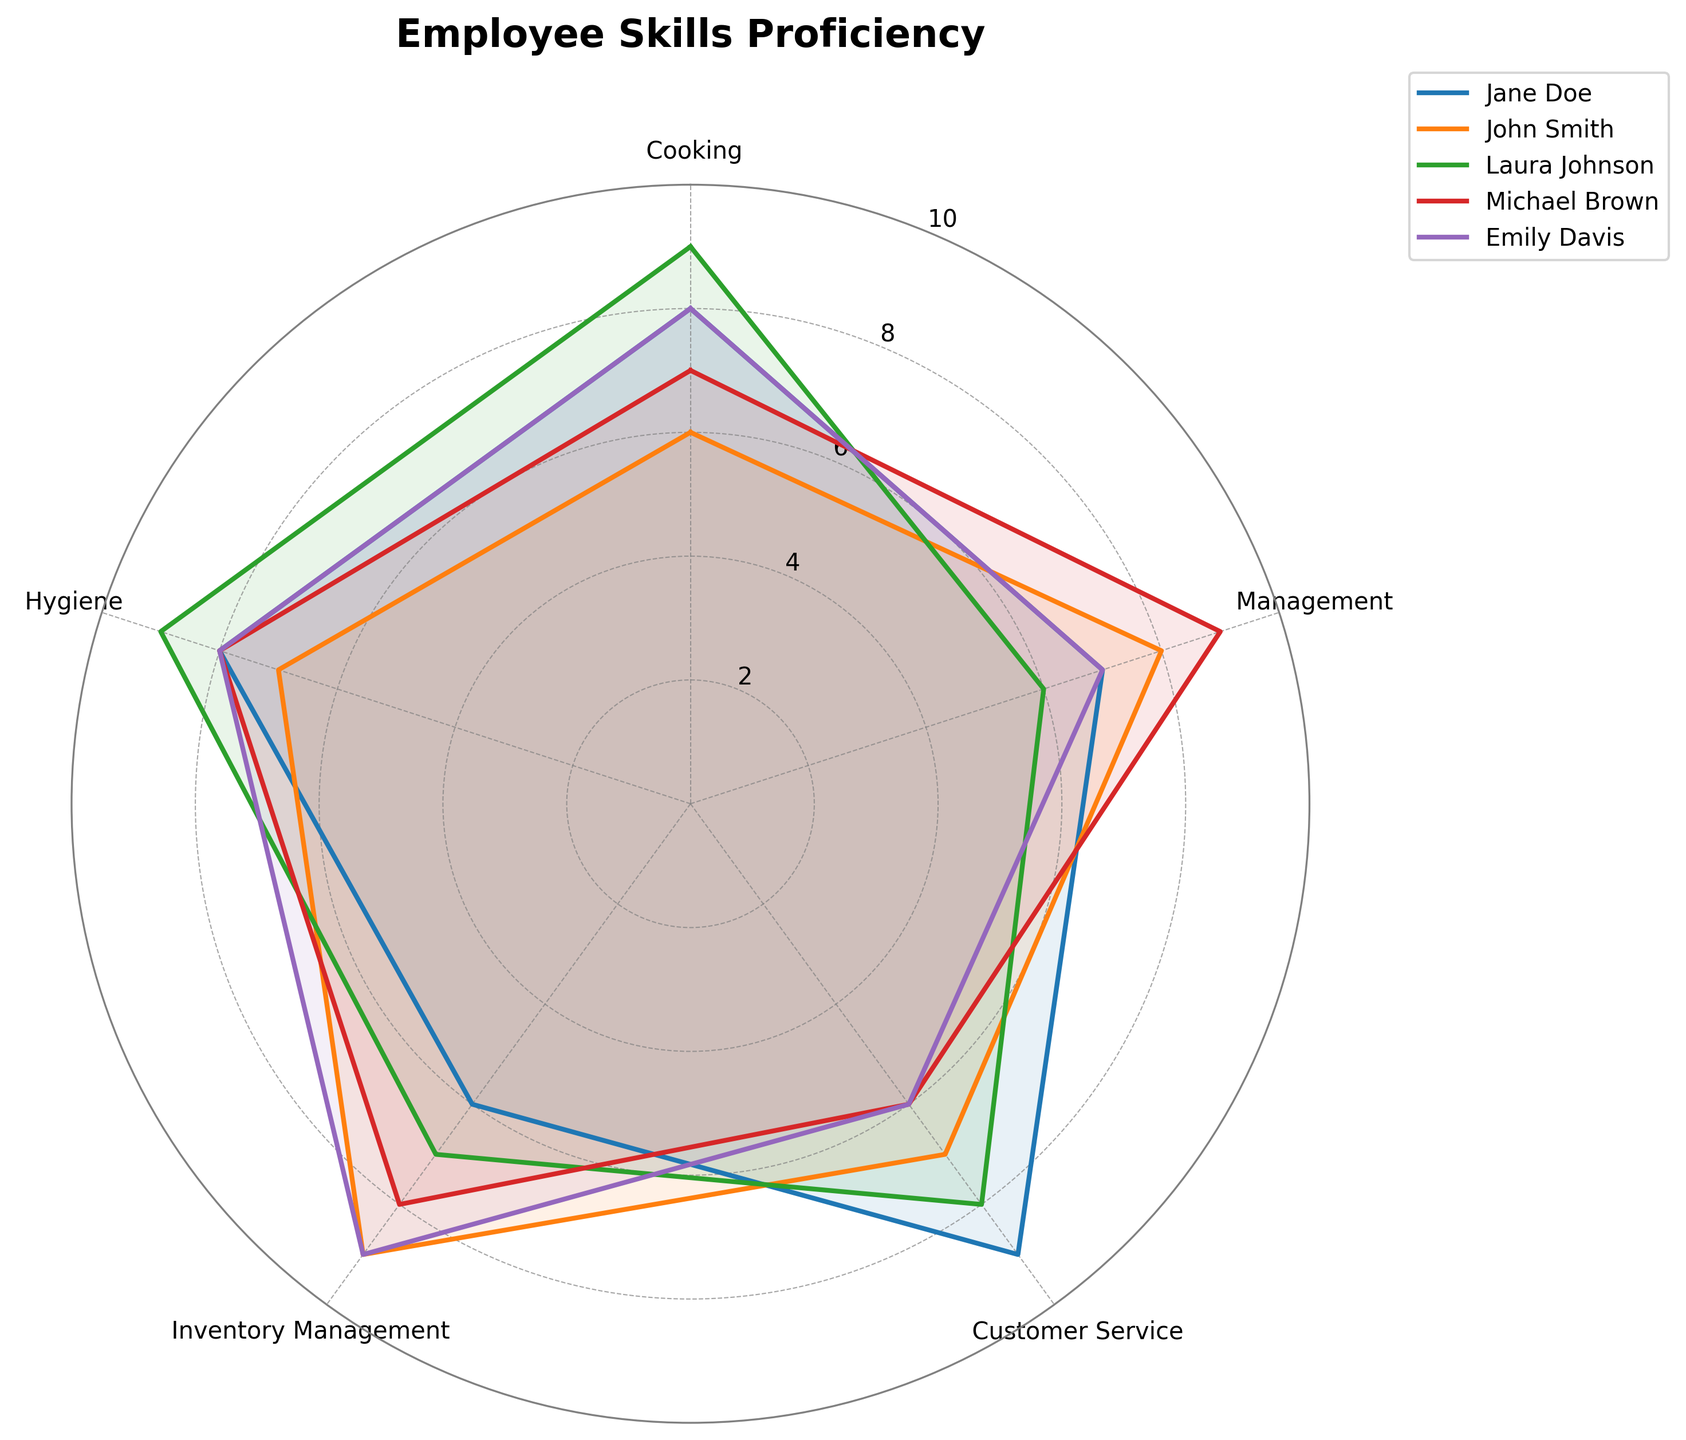Which employee has the highest proficiency in Cooking? By observing the chart, the values on the Cooking axis, Laura Johnson has the highest proficiency with a value of 9.
Answer: Laura Johnson Who has the lowest proficiency in Customer Service? Looking at the Customer Service axis, both Michael Brown and Emily Davis have the lowest proficiency with values of 6.
Answer: Michael Brown and Emily Davis What is the average score of Hygiene proficiency among all employees? The Hygiene scores are 8, 7, 9, 8, 8. Sum these to get 40, then divide by 5. The average score is 40 / 5 = 8.
Answer: 8 Compare Laura Johnson and John Smith’s scores in Inventory Management. Who is better? John Smith has a score of 9 while Laura Johnson has a score of 7 in Inventory Management. Therefore, John Smith is better.
Answer: John Smith Which skill has the most variability across employees? By examining the chart, Customer Service shows a range from 6 to 9, which is the widest range among all skills, indicating the most variability.
Answer: Customer Service Which employee has the most balanced proficiency across all skills? The employee whose radar chart forms the most consistent shape without sharp deviations. Emily Davis's chart appears to be the most balanced.
Answer: Emily Davis For Jane Doe, which skill needs the most improvement? Jane Doe has the lowest score in Inventory Management with a value of 6, indicating it needs the most improvement.
Answer: Inventory Management If you were to prioritize Management training, which employee(s) would benefit the most? The employees with the lowest scores in Management are Laura Johnson and Jane Doe, both at 6 and 7, respectively. Laura Johnson would benefit the most.
Answer: Laura Johnson Calculate the total proficiency score for Michael Brown across all skills. Add up all his scores: 7 (Cooking) + 9 (Management) + 6 (Customer Service) + 8 (Inventory Management) + 8 (Hygiene) = 38.
Answer: 38 